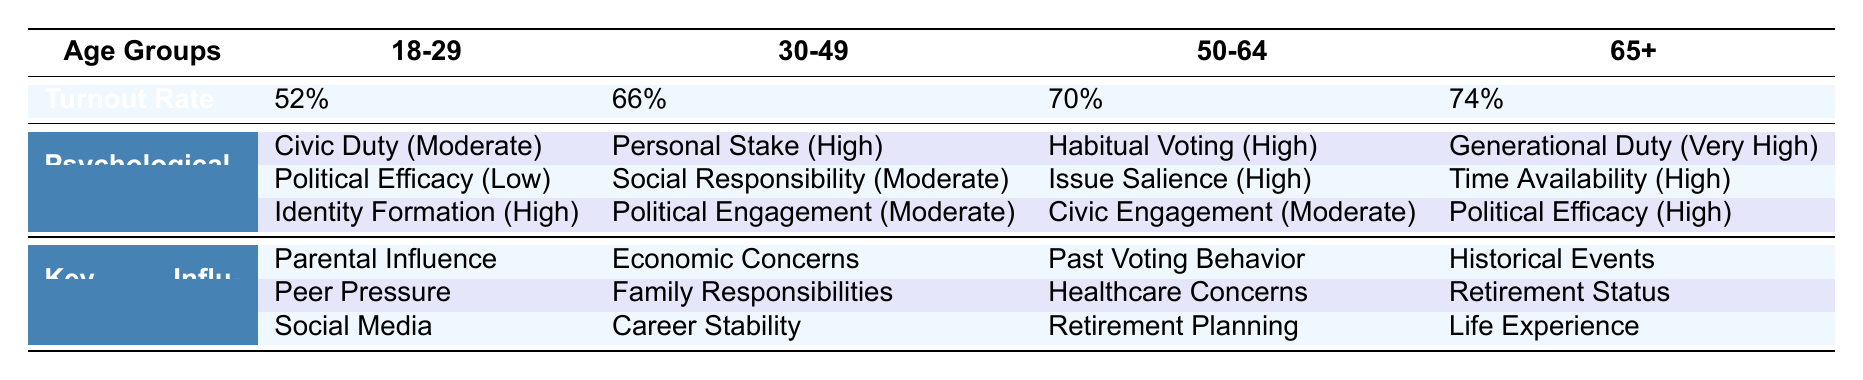What is the turnout rate for the age group 30-49? The table lists the turnout rate for each age group. For the age group 30-49, the turnout rate is specified as 66%.
Answer: 66% Which psychological factor has the highest impact level for the age group 65+? Looking at the Psychological Factors row for the age group 65+, the factor "Generational Duty" is listed and has the highest impact level of "Very High".
Answer: Generational Duty Is the impact level of "Political Efficacy" the same across all age groups? The impact levels of "Political Efficacy" vary across age groups. For 18-29, it's Low; for 30-49, it's Moderate; for 50-64, it's High; and for 65+, it's High. Therefore, they are not the same.
Answer: No How does the turnout rate change from the age group 18-29 to 65+? The turnout rate for 18-29 is 52%, while for 65+ it is 74%. To find the change, we calculate 74% - 52% = 22%. Thus, there is an increase of 22 percentage points in turnout rate.
Answer: Increased by 22% What are the key influencers for "Civic Duty" in the 18-29 age group? The table lists the key influencers for "Civic Duty" under the 18-29 age group as "Parental Influence", "Peer Pressure", and "Social Media".
Answer: Parental Influence, Peer Pressure, Social Media Which age group exhibits the highest average impact level for the listed psychological factors? First, we note the impact levels: for age group 18-29 (Moderate, Low, High), the average is calculated as 3 (Moderate=2, Low=1, High=3, total of 6 and divided by 3 for average = 2). For 30-49 (High, Moderate, Moderate), the average is 2.67. For 50-64 (High, High, Moderate), the average is 2.67. For 65+ (Very High, High, High), it's 3.67 (Very High=4, High=3, and another High=3). The age group 65+ has the highest average impact level of 3.67.
Answer: 65+ Are there any psychological factors that share the same impact level in the age group 50-64? In the psychological factors listed for 50-64, "Habitual Voting" and "Issue Salience" both have an impact level of High, while "Civic Engagement" has a Moderate impact level. Hence, yes, there are two factors with the same impact level.
Answer: Yes How many psychological factors are listed for the age group 30-49, and what is the general trend of their impact levels? There are three psychological factors listed for the age group 30-49: "Personal Stake" (High), "Social Responsibility" (Moderate), and "Political Engagement" (Moderate). The trend shows one High and two Moderate levels.
Answer: Three factors; one High, two Moderate 